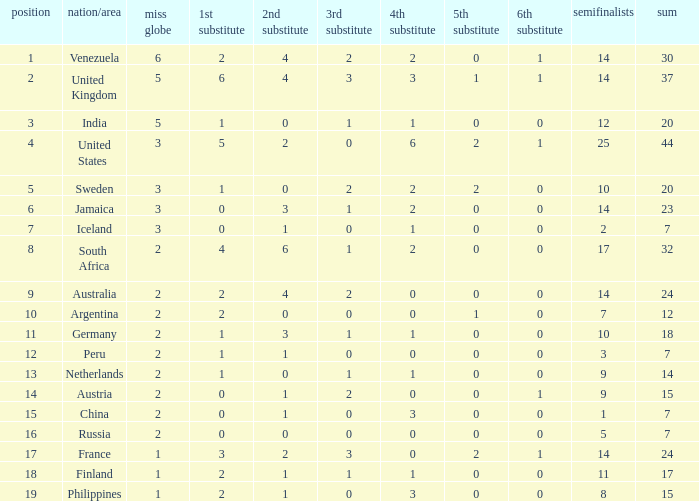What is Venezuela's total rank? 30.0. 